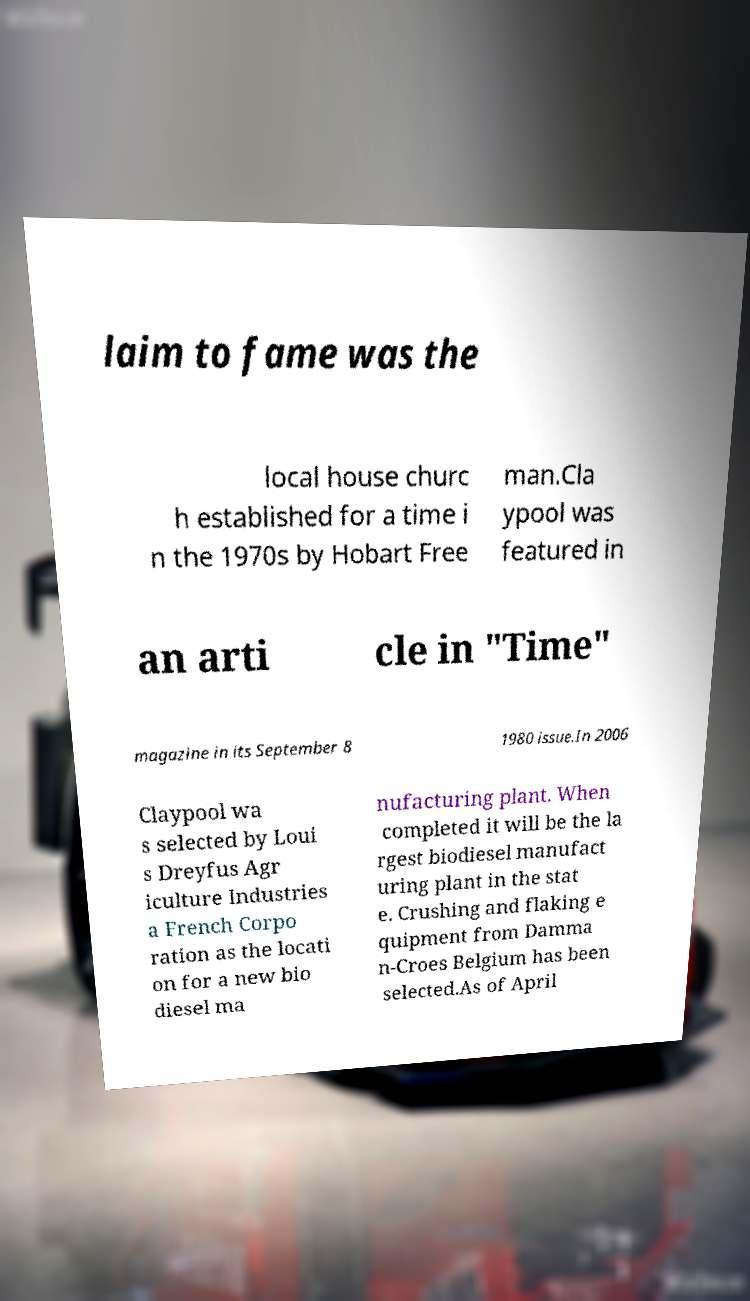What messages or text are displayed in this image? I need them in a readable, typed format. laim to fame was the local house churc h established for a time i n the 1970s by Hobart Free man.Cla ypool was featured in an arti cle in "Time" magazine in its September 8 1980 issue.In 2006 Claypool wa s selected by Loui s Dreyfus Agr iculture Industries a French Corpo ration as the locati on for a new bio diesel ma nufacturing plant. When completed it will be the la rgest biodiesel manufact uring plant in the stat e. Crushing and flaking e quipment from Damma n-Croes Belgium has been selected.As of April 